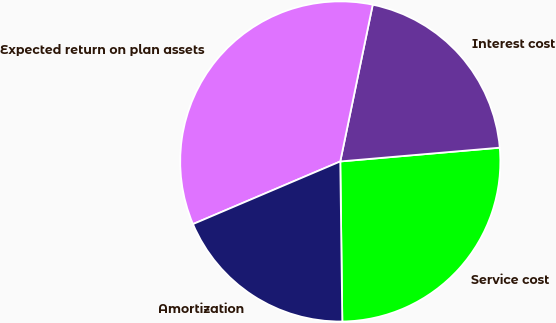Convert chart to OTSL. <chart><loc_0><loc_0><loc_500><loc_500><pie_chart><fcel>Service cost<fcel>Interest cost<fcel>Expected return on plan assets<fcel>Amortization<nl><fcel>26.17%<fcel>20.38%<fcel>34.65%<fcel>18.8%<nl></chart> 